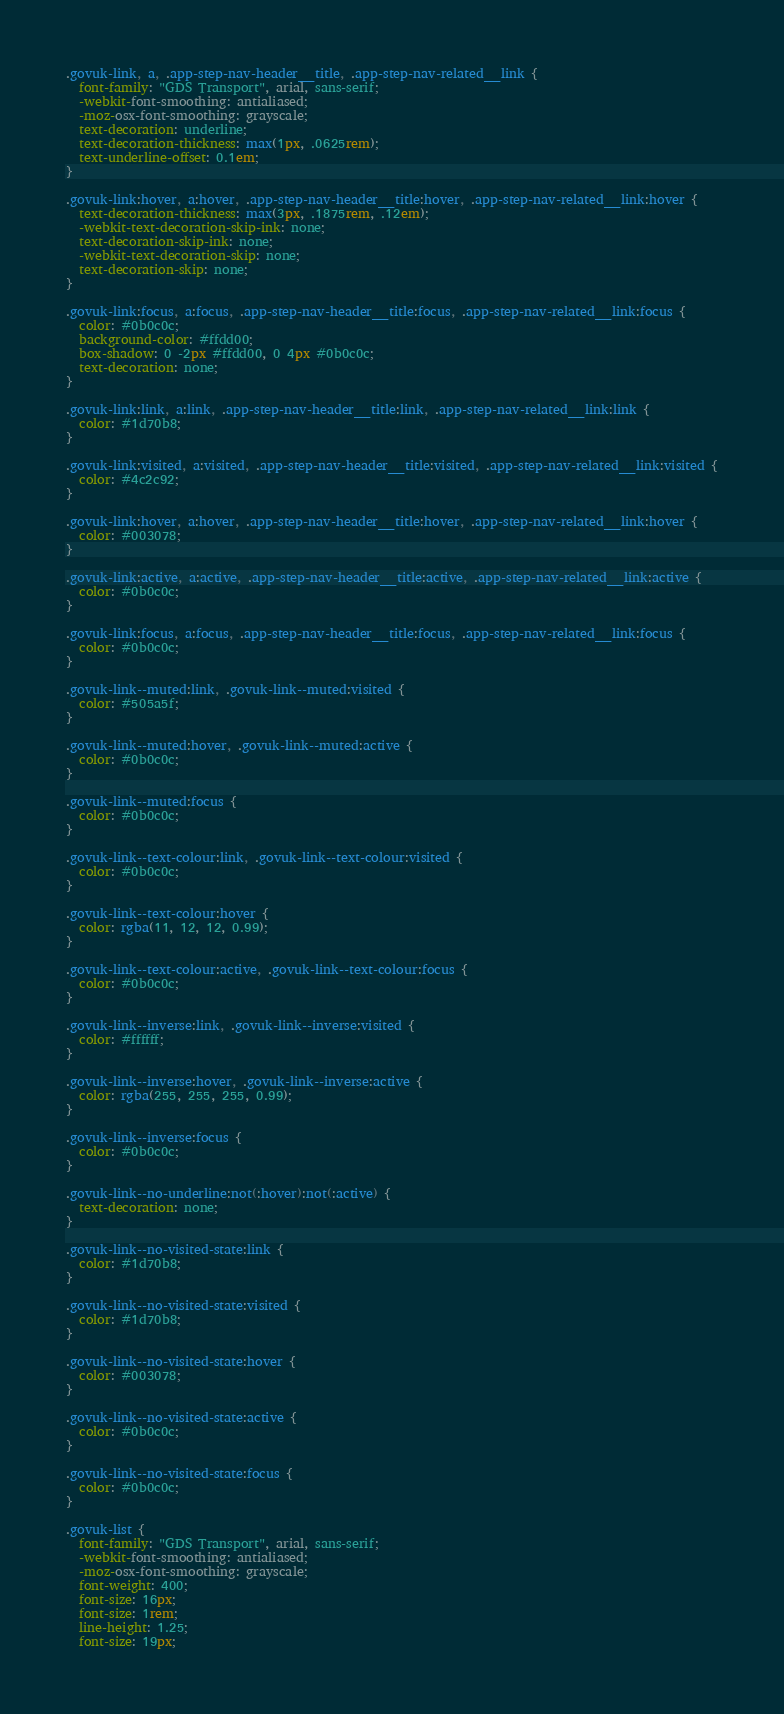Convert code to text. <code><loc_0><loc_0><loc_500><loc_500><_CSS_>.govuk-link, a, .app-step-nav-header__title, .app-step-nav-related__link {
  font-family: "GDS Transport", arial, sans-serif;
  -webkit-font-smoothing: antialiased;
  -moz-osx-font-smoothing: grayscale;
  text-decoration: underline;
  text-decoration-thickness: max(1px, .0625rem);
  text-underline-offset: 0.1em;
}

.govuk-link:hover, a:hover, .app-step-nav-header__title:hover, .app-step-nav-related__link:hover {
  text-decoration-thickness: max(3px, .1875rem, .12em);
  -webkit-text-decoration-skip-ink: none;
  text-decoration-skip-ink: none;
  -webkit-text-decoration-skip: none;
  text-decoration-skip: none;
}

.govuk-link:focus, a:focus, .app-step-nav-header__title:focus, .app-step-nav-related__link:focus {
  color: #0b0c0c;
  background-color: #ffdd00;
  box-shadow: 0 -2px #ffdd00, 0 4px #0b0c0c;
  text-decoration: none;
}

.govuk-link:link, a:link, .app-step-nav-header__title:link, .app-step-nav-related__link:link {
  color: #1d70b8;
}

.govuk-link:visited, a:visited, .app-step-nav-header__title:visited, .app-step-nav-related__link:visited {
  color: #4c2c92;
}

.govuk-link:hover, a:hover, .app-step-nav-header__title:hover, .app-step-nav-related__link:hover {
  color: #003078;
}

.govuk-link:active, a:active, .app-step-nav-header__title:active, .app-step-nav-related__link:active {
  color: #0b0c0c;
}

.govuk-link:focus, a:focus, .app-step-nav-header__title:focus, .app-step-nav-related__link:focus {
  color: #0b0c0c;
}

.govuk-link--muted:link, .govuk-link--muted:visited {
  color: #505a5f;
}

.govuk-link--muted:hover, .govuk-link--muted:active {
  color: #0b0c0c;
}

.govuk-link--muted:focus {
  color: #0b0c0c;
}

.govuk-link--text-colour:link, .govuk-link--text-colour:visited {
  color: #0b0c0c;
}

.govuk-link--text-colour:hover {
  color: rgba(11, 12, 12, 0.99);
}

.govuk-link--text-colour:active, .govuk-link--text-colour:focus {
  color: #0b0c0c;
}

.govuk-link--inverse:link, .govuk-link--inverse:visited {
  color: #ffffff;
}

.govuk-link--inverse:hover, .govuk-link--inverse:active {
  color: rgba(255, 255, 255, 0.99);
}

.govuk-link--inverse:focus {
  color: #0b0c0c;
}

.govuk-link--no-underline:not(:hover):not(:active) {
  text-decoration: none;
}

.govuk-link--no-visited-state:link {
  color: #1d70b8;
}

.govuk-link--no-visited-state:visited {
  color: #1d70b8;
}

.govuk-link--no-visited-state:hover {
  color: #003078;
}

.govuk-link--no-visited-state:active {
  color: #0b0c0c;
}

.govuk-link--no-visited-state:focus {
  color: #0b0c0c;
}

.govuk-list {
  font-family: "GDS Transport", arial, sans-serif;
  -webkit-font-smoothing: antialiased;
  -moz-osx-font-smoothing: grayscale;
  font-weight: 400;
  font-size: 16px;
  font-size: 1rem;
  line-height: 1.25;
  font-size: 19px;</code> 